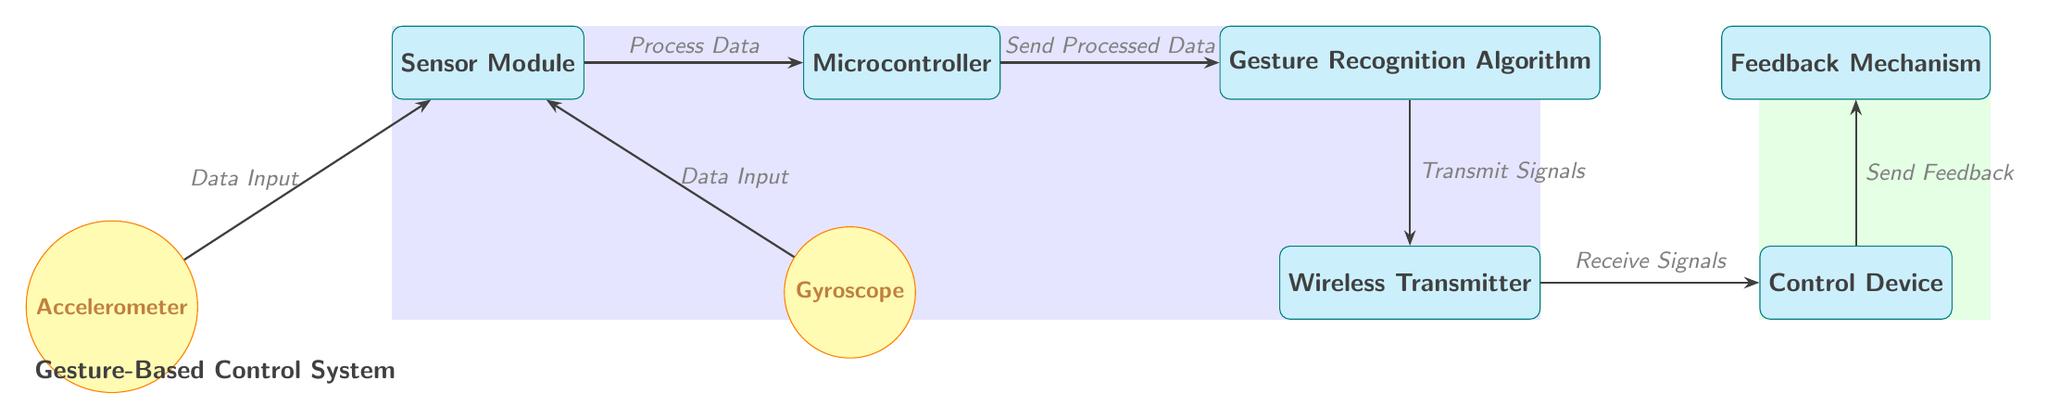What is the shape of the Sensor Module? The Sensor Module is represented as a rectangle, which is typical for indicating a box or module in a diagram.
Answer: rectangle How many sensors are in the diagram? There are two sensors depicted in the diagram: an Accelerometer and a Gyroscope.
Answer: 2 What signals does the Wireless Transmitter send? The Wireless Transmitter communicates signals to the Control Device after receiving processed data.
Answer: Transmit Signals In which direction does data flow from the Accelerometer to the Microcontroller? The data flows from the Accelerometer to the Microcontroller in a rightward direction as indicated by the arrow.
Answer: right What is the relationship between the gesture recognition and feedback mechanism in the control device? The relationship is that the Control Device sends feedback to the Feedback Mechanism, indicating a two-way communication flow between these components.
Answer: Send Feedback What is the flow of data after it is processed by the Microcontroller? After processing, the data is sent to the Gesture Recognition Algorithm; this is a linear flow illustrated by the arrow connecting the two nodes.
Answer: Send Processed Data Which component is located directly above the Control Device? The component that is positioned directly above the Control Device is the Feedback Mechanism, as indicated by their relative positioning in the diagram.
Answer: Feedback Mechanism What happens to the data after it flows from the Gesture Recognition Algorithm? Once the data flows from the Gesture Recognition Algorithm, it is transmitted to the Wireless Transmitter. This flow is indicated by the diagram's arrows illustrating the data paths.
Answer: Transmit Signals What color represents the sensors in the diagram? The sensors, including the Accelerometer and Gyroscope, are represented in yellow color.
Answer: yellow 